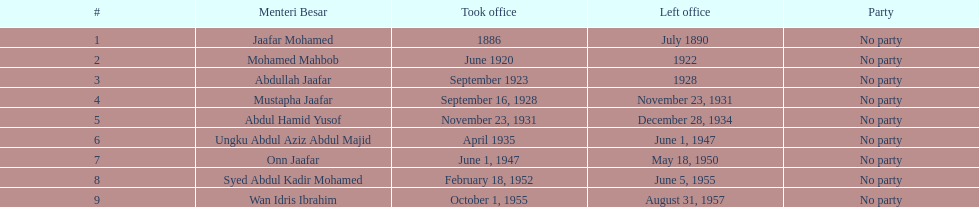Who spend the most amount of time in office? Ungku Abdul Aziz Abdul Majid. 